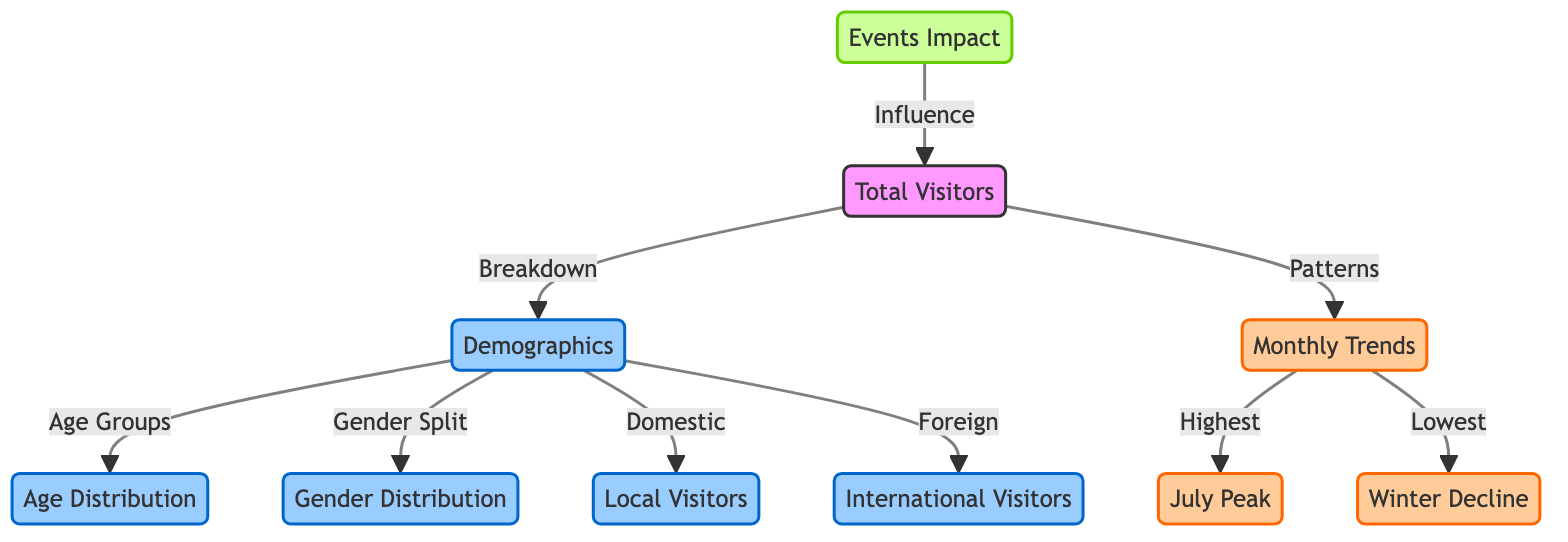What do the total visitors connect to in the diagram? The total visitors node connects to two nodes: demographics and monthly trends, indicating the breakdown of visitor demographics and the patterns of visitor statistics over time.
Answer: demographics, monthly trends What does the demographics node break down into? The demographics node breaks down into four nodes: age distribution, gender distribution, local visitors, and international visitors, displaying the different categories within visitor demographics.
Answer: age distribution, gender distribution, local visitors, international visitors Which month has the highest visitor count according to the diagram? The monthly trends node indicates that July is noted as the peak month for visitor counts, as represented by the connection to the July Peak node.
Answer: July What factors contribute to the decline in visitors during winter? The winter decline is linked from the monthly trends node, which signifies that winter months have a lower visitor count compared to other times of the year, based on overall monthly trends.
Answer: Winter What type of visitors are linked to the demographics node? The demographics node connects to local visitors and international visitors, representing both domestic and foreign visitors in the statistics.
Answer: local visitors, international visitors How does the events node influence total visitors? The events node indicates an influence on total visitors, suggesting that events held at the park likely attract more visitors, enhancing overall visitor statistics.
Answer: Events Impact What is the relation between age distribution and demographics? The age distribution node is a direct breakdown category under the demographics node, representing how visitor numbers vary across different age groups within the overall demographics.
Answer: Age Groups Identify the trend pattern of visitors in winter? The winter trend is indicated to show a decline in visitors as highlighted by the connection to the winter decline node, which reflects lower visitor statistics during these months.
Answer: Decline 